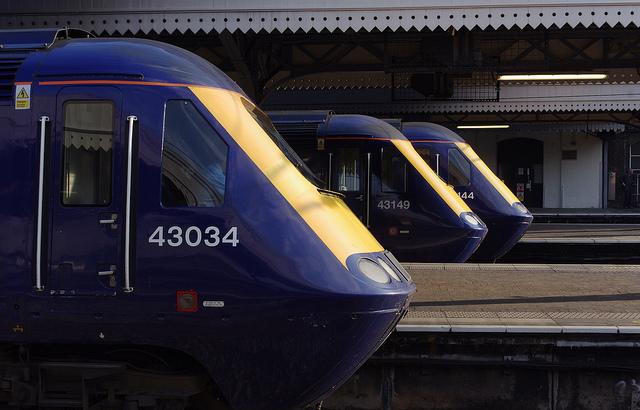What surface allows the trains to be mobile? Please explain your reasoning. rails. Trains are not road vehicles. they cannot travel on pavement, cement, or asphalt. 